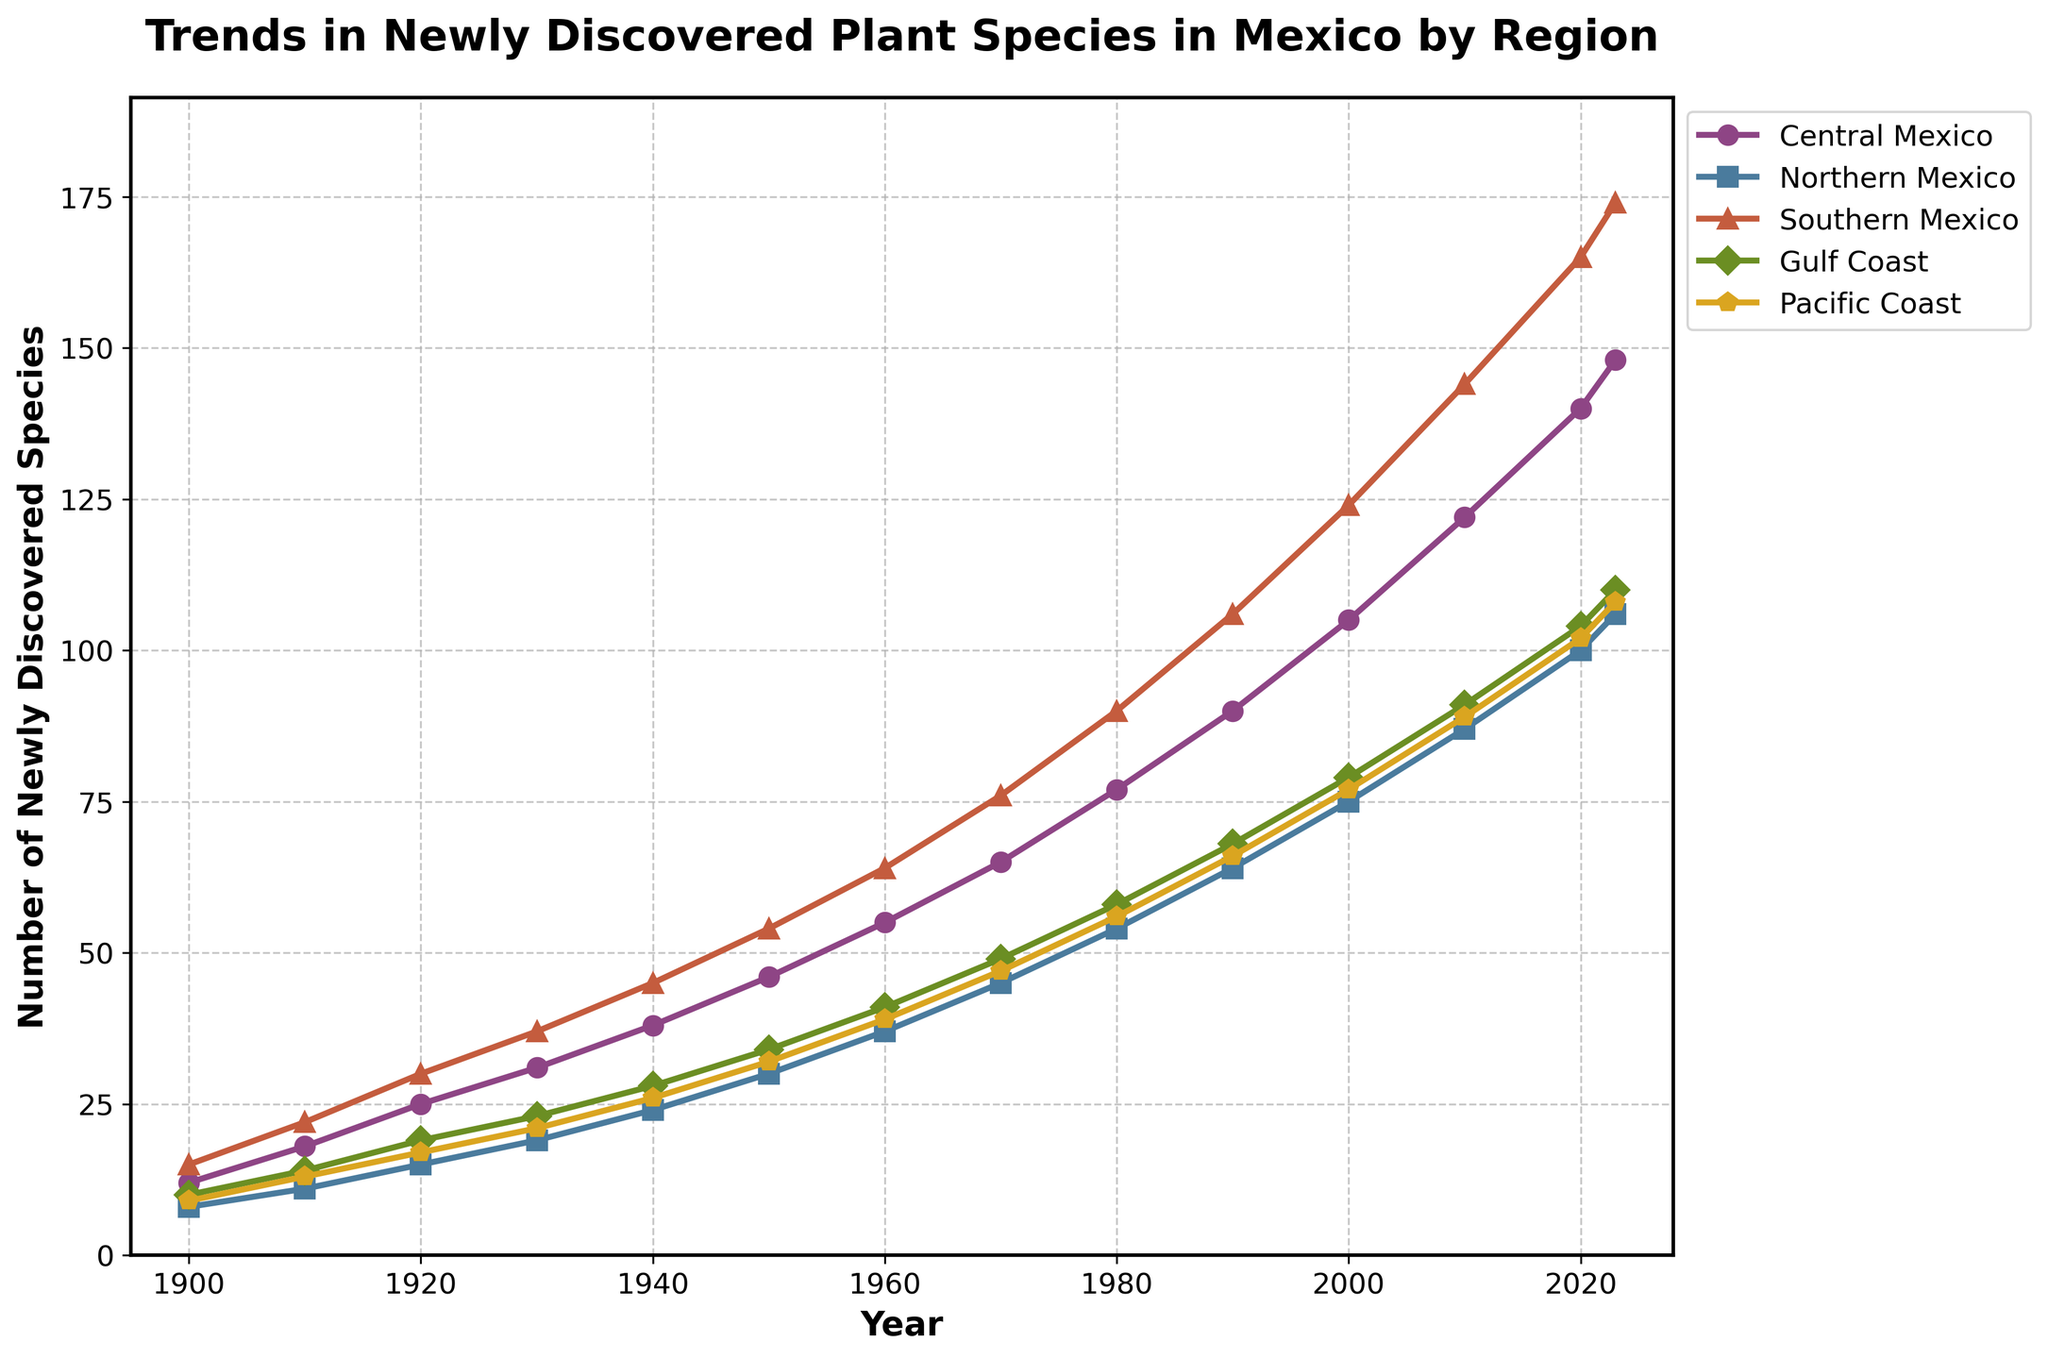What is the trend in the number of newly discovered plant species in Central Mexico from 1900 to 2023? The trend in Central Mexico shows a consistent increase. From 12 species in 1900 to 148 species in 2023. The values keep rising in each decade without any decrease.
Answer: Increase Which region had the highest number of newly discovered species in 2000? In 2000, Southern Mexico had 124 newly discovered species, higher than any other region which are Central Mexico (105), Northern Mexico (75), Gulf Coast (79), Pacific Coast (77).
Answer: Southern Mexico How does the number of newly discovered species in Northern Mexico in 2020 compare to Southern Mexico in 2020? In 2020, Northern Mexico had 100 species, whereas Southern Mexico had 165 species. Thus, Southern Mexico had 65 more species discovered than Northern Mexico in 2020.
Answer: Southern Mexico; 65 more What is the difference in the number of newly discovered species between Central Mexico in 1910 and 1930? Central Mexico had 18 species in 1910 and 31 species in 1930. The difference is 31 - 18 = 13.
Answer: 13 Which region has the smallest growth in newly discovered species from 1900 to 2023? To find this, we subtract the 1900 value from the 2023 value for each region: Central Mexico (148-12=136), Northern Mexico (106-8=98), Southern Mexico (174-15=159), Gulf Coast (110-10=100), Pacific Coast (108-9=99). Northern Mexico shows the smallest growth.
Answer: Northern Mexico How many newly discovered species were recorded in the Gulf Coast in 1950 and 1960 combined? Gulf Coast recorded 34 species in 1950 and 41 in 1960. Combined, this is 34 + 41 = 75.
Answer: 75 Which two regions show a similar trend in terms of newly discovered species from 2000 to 2023? Examining 2000 to 2023, Central Mexico (105 to 148) and Gulf Coast (79 to 110) have both increased by increments of similar magnitude. Central Mexico increased by 43, Gulf Coast by 31.
Answer: Central Mexico, Gulf Coast What pattern is noticeable in the data for Southern Mexico from 1900 to 2023? Southern Mexico shows a consistent increase in the number of newly discovered species each decade, without any fluctuations or decreases, starting from 15 in 1900 to 174 in 2023.
Answer: Consistent increase By how much did the number of newly discovered species in Central Mexico increase in the last decade (2010-2020)? In 2010, Central Mexico had 122 species; in 2020, it had 140. The increase is 140 - 122 = 18.
Answer: 18 